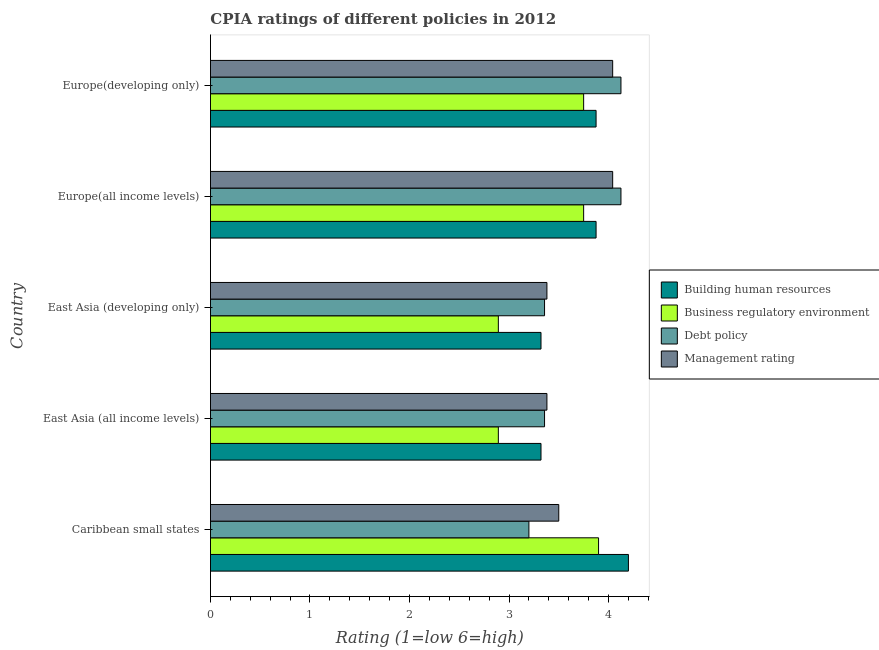What is the label of the 5th group of bars from the top?
Your answer should be compact. Caribbean small states. What is the cpia rating of debt policy in Europe(all income levels)?
Your response must be concise. 4.12. Across all countries, what is the maximum cpia rating of management?
Keep it short and to the point. 4.04. Across all countries, what is the minimum cpia rating of management?
Offer a terse response. 3.38. In which country was the cpia rating of building human resources maximum?
Offer a terse response. Caribbean small states. In which country was the cpia rating of business regulatory environment minimum?
Ensure brevity in your answer.  East Asia (all income levels). What is the total cpia rating of building human resources in the graph?
Make the answer very short. 18.59. What is the difference between the cpia rating of debt policy in East Asia (all income levels) and that in Europe(developing only)?
Provide a short and direct response. -0.77. What is the difference between the cpia rating of building human resources in East Asia (all income levels) and the cpia rating of debt policy in East Asia (developing only)?
Your response must be concise. -0.04. What is the average cpia rating of business regulatory environment per country?
Offer a terse response. 3.44. What is the difference between the cpia rating of business regulatory environment and cpia rating of building human resources in Europe(all income levels)?
Your answer should be compact. -0.12. What is the ratio of the cpia rating of building human resources in East Asia (all income levels) to that in East Asia (developing only)?
Provide a short and direct response. 1. Is the cpia rating of management in East Asia (all income levels) less than that in East Asia (developing only)?
Your answer should be compact. No. Is the difference between the cpia rating of management in Caribbean small states and East Asia (developing only) greater than the difference between the cpia rating of building human resources in Caribbean small states and East Asia (developing only)?
Your response must be concise. No. What is the difference between the highest and the second highest cpia rating of building human resources?
Give a very brief answer. 0.33. What is the difference between the highest and the lowest cpia rating of management?
Your answer should be compact. 0.66. What does the 2nd bar from the top in Caribbean small states represents?
Offer a terse response. Debt policy. What does the 4th bar from the bottom in Europe(developing only) represents?
Provide a succinct answer. Management rating. How many bars are there?
Give a very brief answer. 20. Are all the bars in the graph horizontal?
Give a very brief answer. Yes. How many countries are there in the graph?
Your response must be concise. 5. Are the values on the major ticks of X-axis written in scientific E-notation?
Offer a very short reply. No. Where does the legend appear in the graph?
Make the answer very short. Center right. How many legend labels are there?
Your answer should be compact. 4. What is the title of the graph?
Your response must be concise. CPIA ratings of different policies in 2012. What is the label or title of the X-axis?
Ensure brevity in your answer.  Rating (1=low 6=high). What is the Rating (1=low 6=high) in Building human resources in Caribbean small states?
Offer a terse response. 4.2. What is the Rating (1=low 6=high) in Building human resources in East Asia (all income levels)?
Offer a terse response. 3.32. What is the Rating (1=low 6=high) of Business regulatory environment in East Asia (all income levels)?
Provide a succinct answer. 2.89. What is the Rating (1=low 6=high) in Debt policy in East Asia (all income levels)?
Keep it short and to the point. 3.36. What is the Rating (1=low 6=high) of Management rating in East Asia (all income levels)?
Offer a very short reply. 3.38. What is the Rating (1=low 6=high) of Building human resources in East Asia (developing only)?
Provide a succinct answer. 3.32. What is the Rating (1=low 6=high) in Business regulatory environment in East Asia (developing only)?
Provide a succinct answer. 2.89. What is the Rating (1=low 6=high) of Debt policy in East Asia (developing only)?
Your answer should be very brief. 3.36. What is the Rating (1=low 6=high) in Management rating in East Asia (developing only)?
Provide a short and direct response. 3.38. What is the Rating (1=low 6=high) of Building human resources in Europe(all income levels)?
Make the answer very short. 3.88. What is the Rating (1=low 6=high) of Business regulatory environment in Europe(all income levels)?
Offer a terse response. 3.75. What is the Rating (1=low 6=high) of Debt policy in Europe(all income levels)?
Provide a succinct answer. 4.12. What is the Rating (1=low 6=high) of Management rating in Europe(all income levels)?
Offer a terse response. 4.04. What is the Rating (1=low 6=high) in Building human resources in Europe(developing only)?
Ensure brevity in your answer.  3.88. What is the Rating (1=low 6=high) in Business regulatory environment in Europe(developing only)?
Give a very brief answer. 3.75. What is the Rating (1=low 6=high) in Debt policy in Europe(developing only)?
Offer a terse response. 4.12. What is the Rating (1=low 6=high) of Management rating in Europe(developing only)?
Offer a terse response. 4.04. Across all countries, what is the maximum Rating (1=low 6=high) of Building human resources?
Give a very brief answer. 4.2. Across all countries, what is the maximum Rating (1=low 6=high) of Business regulatory environment?
Keep it short and to the point. 3.9. Across all countries, what is the maximum Rating (1=low 6=high) in Debt policy?
Provide a short and direct response. 4.12. Across all countries, what is the maximum Rating (1=low 6=high) of Management rating?
Offer a terse response. 4.04. Across all countries, what is the minimum Rating (1=low 6=high) in Building human resources?
Keep it short and to the point. 3.32. Across all countries, what is the minimum Rating (1=low 6=high) of Business regulatory environment?
Offer a very short reply. 2.89. Across all countries, what is the minimum Rating (1=low 6=high) of Debt policy?
Keep it short and to the point. 3.2. Across all countries, what is the minimum Rating (1=low 6=high) in Management rating?
Give a very brief answer. 3.38. What is the total Rating (1=low 6=high) in Building human resources in the graph?
Your response must be concise. 18.59. What is the total Rating (1=low 6=high) in Business regulatory environment in the graph?
Provide a short and direct response. 17.19. What is the total Rating (1=low 6=high) of Debt policy in the graph?
Ensure brevity in your answer.  18.16. What is the total Rating (1=low 6=high) of Management rating in the graph?
Your answer should be compact. 18.35. What is the difference between the Rating (1=low 6=high) in Building human resources in Caribbean small states and that in East Asia (all income levels)?
Your response must be concise. 0.88. What is the difference between the Rating (1=low 6=high) of Business regulatory environment in Caribbean small states and that in East Asia (all income levels)?
Keep it short and to the point. 1.01. What is the difference between the Rating (1=low 6=high) in Debt policy in Caribbean small states and that in East Asia (all income levels)?
Provide a succinct answer. -0.16. What is the difference between the Rating (1=low 6=high) of Management rating in Caribbean small states and that in East Asia (all income levels)?
Your answer should be compact. 0.12. What is the difference between the Rating (1=low 6=high) in Building human resources in Caribbean small states and that in East Asia (developing only)?
Your answer should be very brief. 0.88. What is the difference between the Rating (1=low 6=high) in Business regulatory environment in Caribbean small states and that in East Asia (developing only)?
Provide a succinct answer. 1.01. What is the difference between the Rating (1=low 6=high) of Debt policy in Caribbean small states and that in East Asia (developing only)?
Your answer should be compact. -0.16. What is the difference between the Rating (1=low 6=high) of Management rating in Caribbean small states and that in East Asia (developing only)?
Your answer should be very brief. 0.12. What is the difference between the Rating (1=low 6=high) of Building human resources in Caribbean small states and that in Europe(all income levels)?
Keep it short and to the point. 0.33. What is the difference between the Rating (1=low 6=high) in Debt policy in Caribbean small states and that in Europe(all income levels)?
Keep it short and to the point. -0.93. What is the difference between the Rating (1=low 6=high) in Management rating in Caribbean small states and that in Europe(all income levels)?
Ensure brevity in your answer.  -0.54. What is the difference between the Rating (1=low 6=high) of Building human resources in Caribbean small states and that in Europe(developing only)?
Provide a succinct answer. 0.33. What is the difference between the Rating (1=low 6=high) in Business regulatory environment in Caribbean small states and that in Europe(developing only)?
Your answer should be very brief. 0.15. What is the difference between the Rating (1=low 6=high) in Debt policy in Caribbean small states and that in Europe(developing only)?
Offer a terse response. -0.93. What is the difference between the Rating (1=low 6=high) in Management rating in Caribbean small states and that in Europe(developing only)?
Make the answer very short. -0.54. What is the difference between the Rating (1=low 6=high) in Debt policy in East Asia (all income levels) and that in East Asia (developing only)?
Your answer should be compact. 0. What is the difference between the Rating (1=low 6=high) in Building human resources in East Asia (all income levels) and that in Europe(all income levels)?
Your answer should be compact. -0.55. What is the difference between the Rating (1=low 6=high) of Business regulatory environment in East Asia (all income levels) and that in Europe(all income levels)?
Offer a very short reply. -0.86. What is the difference between the Rating (1=low 6=high) in Debt policy in East Asia (all income levels) and that in Europe(all income levels)?
Offer a very short reply. -0.77. What is the difference between the Rating (1=low 6=high) of Management rating in East Asia (all income levels) and that in Europe(all income levels)?
Your answer should be very brief. -0.66. What is the difference between the Rating (1=low 6=high) of Building human resources in East Asia (all income levels) and that in Europe(developing only)?
Your response must be concise. -0.55. What is the difference between the Rating (1=low 6=high) of Business regulatory environment in East Asia (all income levels) and that in Europe(developing only)?
Provide a short and direct response. -0.86. What is the difference between the Rating (1=low 6=high) in Debt policy in East Asia (all income levels) and that in Europe(developing only)?
Offer a terse response. -0.77. What is the difference between the Rating (1=low 6=high) in Management rating in East Asia (all income levels) and that in Europe(developing only)?
Offer a terse response. -0.66. What is the difference between the Rating (1=low 6=high) of Building human resources in East Asia (developing only) and that in Europe(all income levels)?
Keep it short and to the point. -0.55. What is the difference between the Rating (1=low 6=high) of Business regulatory environment in East Asia (developing only) and that in Europe(all income levels)?
Your response must be concise. -0.86. What is the difference between the Rating (1=low 6=high) of Debt policy in East Asia (developing only) and that in Europe(all income levels)?
Offer a very short reply. -0.77. What is the difference between the Rating (1=low 6=high) of Management rating in East Asia (developing only) and that in Europe(all income levels)?
Your answer should be compact. -0.66. What is the difference between the Rating (1=low 6=high) of Building human resources in East Asia (developing only) and that in Europe(developing only)?
Keep it short and to the point. -0.55. What is the difference between the Rating (1=low 6=high) in Business regulatory environment in East Asia (developing only) and that in Europe(developing only)?
Provide a short and direct response. -0.86. What is the difference between the Rating (1=low 6=high) of Debt policy in East Asia (developing only) and that in Europe(developing only)?
Your answer should be compact. -0.77. What is the difference between the Rating (1=low 6=high) in Management rating in East Asia (developing only) and that in Europe(developing only)?
Make the answer very short. -0.66. What is the difference between the Rating (1=low 6=high) in Building human resources in Europe(all income levels) and that in Europe(developing only)?
Your answer should be very brief. 0. What is the difference between the Rating (1=low 6=high) in Debt policy in Europe(all income levels) and that in Europe(developing only)?
Give a very brief answer. 0. What is the difference between the Rating (1=low 6=high) in Building human resources in Caribbean small states and the Rating (1=low 6=high) in Business regulatory environment in East Asia (all income levels)?
Offer a terse response. 1.31. What is the difference between the Rating (1=low 6=high) of Building human resources in Caribbean small states and the Rating (1=low 6=high) of Debt policy in East Asia (all income levels)?
Offer a terse response. 0.84. What is the difference between the Rating (1=low 6=high) of Building human resources in Caribbean small states and the Rating (1=low 6=high) of Management rating in East Asia (all income levels)?
Provide a succinct answer. 0.82. What is the difference between the Rating (1=low 6=high) in Business regulatory environment in Caribbean small states and the Rating (1=low 6=high) in Debt policy in East Asia (all income levels)?
Keep it short and to the point. 0.54. What is the difference between the Rating (1=low 6=high) of Business regulatory environment in Caribbean small states and the Rating (1=low 6=high) of Management rating in East Asia (all income levels)?
Your answer should be very brief. 0.52. What is the difference between the Rating (1=low 6=high) in Debt policy in Caribbean small states and the Rating (1=low 6=high) in Management rating in East Asia (all income levels)?
Offer a terse response. -0.18. What is the difference between the Rating (1=low 6=high) of Building human resources in Caribbean small states and the Rating (1=low 6=high) of Business regulatory environment in East Asia (developing only)?
Provide a succinct answer. 1.31. What is the difference between the Rating (1=low 6=high) of Building human resources in Caribbean small states and the Rating (1=low 6=high) of Debt policy in East Asia (developing only)?
Keep it short and to the point. 0.84. What is the difference between the Rating (1=low 6=high) of Building human resources in Caribbean small states and the Rating (1=low 6=high) of Management rating in East Asia (developing only)?
Provide a succinct answer. 0.82. What is the difference between the Rating (1=low 6=high) in Business regulatory environment in Caribbean small states and the Rating (1=low 6=high) in Debt policy in East Asia (developing only)?
Provide a short and direct response. 0.54. What is the difference between the Rating (1=low 6=high) of Business regulatory environment in Caribbean small states and the Rating (1=low 6=high) of Management rating in East Asia (developing only)?
Give a very brief answer. 0.52. What is the difference between the Rating (1=low 6=high) of Debt policy in Caribbean small states and the Rating (1=low 6=high) of Management rating in East Asia (developing only)?
Keep it short and to the point. -0.18. What is the difference between the Rating (1=low 6=high) in Building human resources in Caribbean small states and the Rating (1=low 6=high) in Business regulatory environment in Europe(all income levels)?
Your response must be concise. 0.45. What is the difference between the Rating (1=low 6=high) of Building human resources in Caribbean small states and the Rating (1=low 6=high) of Debt policy in Europe(all income levels)?
Your answer should be compact. 0.07. What is the difference between the Rating (1=low 6=high) in Building human resources in Caribbean small states and the Rating (1=low 6=high) in Management rating in Europe(all income levels)?
Provide a succinct answer. 0.16. What is the difference between the Rating (1=low 6=high) of Business regulatory environment in Caribbean small states and the Rating (1=low 6=high) of Debt policy in Europe(all income levels)?
Offer a terse response. -0.23. What is the difference between the Rating (1=low 6=high) in Business regulatory environment in Caribbean small states and the Rating (1=low 6=high) in Management rating in Europe(all income levels)?
Make the answer very short. -0.14. What is the difference between the Rating (1=low 6=high) in Debt policy in Caribbean small states and the Rating (1=low 6=high) in Management rating in Europe(all income levels)?
Keep it short and to the point. -0.84. What is the difference between the Rating (1=low 6=high) in Building human resources in Caribbean small states and the Rating (1=low 6=high) in Business regulatory environment in Europe(developing only)?
Provide a short and direct response. 0.45. What is the difference between the Rating (1=low 6=high) in Building human resources in Caribbean small states and the Rating (1=low 6=high) in Debt policy in Europe(developing only)?
Your answer should be compact. 0.07. What is the difference between the Rating (1=low 6=high) in Building human resources in Caribbean small states and the Rating (1=low 6=high) in Management rating in Europe(developing only)?
Your response must be concise. 0.16. What is the difference between the Rating (1=low 6=high) of Business regulatory environment in Caribbean small states and the Rating (1=low 6=high) of Debt policy in Europe(developing only)?
Make the answer very short. -0.23. What is the difference between the Rating (1=low 6=high) of Business regulatory environment in Caribbean small states and the Rating (1=low 6=high) of Management rating in Europe(developing only)?
Offer a very short reply. -0.14. What is the difference between the Rating (1=low 6=high) of Debt policy in Caribbean small states and the Rating (1=low 6=high) of Management rating in Europe(developing only)?
Offer a very short reply. -0.84. What is the difference between the Rating (1=low 6=high) of Building human resources in East Asia (all income levels) and the Rating (1=low 6=high) of Business regulatory environment in East Asia (developing only)?
Offer a terse response. 0.43. What is the difference between the Rating (1=low 6=high) in Building human resources in East Asia (all income levels) and the Rating (1=low 6=high) in Debt policy in East Asia (developing only)?
Your answer should be very brief. -0.04. What is the difference between the Rating (1=low 6=high) in Building human resources in East Asia (all income levels) and the Rating (1=low 6=high) in Management rating in East Asia (developing only)?
Your response must be concise. -0.06. What is the difference between the Rating (1=low 6=high) of Business regulatory environment in East Asia (all income levels) and the Rating (1=low 6=high) of Debt policy in East Asia (developing only)?
Make the answer very short. -0.46. What is the difference between the Rating (1=low 6=high) of Business regulatory environment in East Asia (all income levels) and the Rating (1=low 6=high) of Management rating in East Asia (developing only)?
Give a very brief answer. -0.49. What is the difference between the Rating (1=low 6=high) in Debt policy in East Asia (all income levels) and the Rating (1=low 6=high) in Management rating in East Asia (developing only)?
Your answer should be very brief. -0.02. What is the difference between the Rating (1=low 6=high) in Building human resources in East Asia (all income levels) and the Rating (1=low 6=high) in Business regulatory environment in Europe(all income levels)?
Keep it short and to the point. -0.43. What is the difference between the Rating (1=low 6=high) in Building human resources in East Asia (all income levels) and the Rating (1=low 6=high) in Debt policy in Europe(all income levels)?
Give a very brief answer. -0.8. What is the difference between the Rating (1=low 6=high) of Building human resources in East Asia (all income levels) and the Rating (1=low 6=high) of Management rating in Europe(all income levels)?
Ensure brevity in your answer.  -0.72. What is the difference between the Rating (1=low 6=high) of Business regulatory environment in East Asia (all income levels) and the Rating (1=low 6=high) of Debt policy in Europe(all income levels)?
Offer a very short reply. -1.23. What is the difference between the Rating (1=low 6=high) of Business regulatory environment in East Asia (all income levels) and the Rating (1=low 6=high) of Management rating in Europe(all income levels)?
Provide a short and direct response. -1.15. What is the difference between the Rating (1=low 6=high) in Debt policy in East Asia (all income levels) and the Rating (1=low 6=high) in Management rating in Europe(all income levels)?
Offer a terse response. -0.68. What is the difference between the Rating (1=low 6=high) of Building human resources in East Asia (all income levels) and the Rating (1=low 6=high) of Business regulatory environment in Europe(developing only)?
Your response must be concise. -0.43. What is the difference between the Rating (1=low 6=high) in Building human resources in East Asia (all income levels) and the Rating (1=low 6=high) in Debt policy in Europe(developing only)?
Make the answer very short. -0.8. What is the difference between the Rating (1=low 6=high) of Building human resources in East Asia (all income levels) and the Rating (1=low 6=high) of Management rating in Europe(developing only)?
Offer a terse response. -0.72. What is the difference between the Rating (1=low 6=high) of Business regulatory environment in East Asia (all income levels) and the Rating (1=low 6=high) of Debt policy in Europe(developing only)?
Offer a very short reply. -1.23. What is the difference between the Rating (1=low 6=high) in Business regulatory environment in East Asia (all income levels) and the Rating (1=low 6=high) in Management rating in Europe(developing only)?
Give a very brief answer. -1.15. What is the difference between the Rating (1=low 6=high) of Debt policy in East Asia (all income levels) and the Rating (1=low 6=high) of Management rating in Europe(developing only)?
Your response must be concise. -0.68. What is the difference between the Rating (1=low 6=high) in Building human resources in East Asia (developing only) and the Rating (1=low 6=high) in Business regulatory environment in Europe(all income levels)?
Ensure brevity in your answer.  -0.43. What is the difference between the Rating (1=low 6=high) in Building human resources in East Asia (developing only) and the Rating (1=low 6=high) in Debt policy in Europe(all income levels)?
Your response must be concise. -0.8. What is the difference between the Rating (1=low 6=high) of Building human resources in East Asia (developing only) and the Rating (1=low 6=high) of Management rating in Europe(all income levels)?
Your answer should be very brief. -0.72. What is the difference between the Rating (1=low 6=high) in Business regulatory environment in East Asia (developing only) and the Rating (1=low 6=high) in Debt policy in Europe(all income levels)?
Make the answer very short. -1.23. What is the difference between the Rating (1=low 6=high) in Business regulatory environment in East Asia (developing only) and the Rating (1=low 6=high) in Management rating in Europe(all income levels)?
Make the answer very short. -1.15. What is the difference between the Rating (1=low 6=high) of Debt policy in East Asia (developing only) and the Rating (1=low 6=high) of Management rating in Europe(all income levels)?
Make the answer very short. -0.68. What is the difference between the Rating (1=low 6=high) in Building human resources in East Asia (developing only) and the Rating (1=low 6=high) in Business regulatory environment in Europe(developing only)?
Give a very brief answer. -0.43. What is the difference between the Rating (1=low 6=high) of Building human resources in East Asia (developing only) and the Rating (1=low 6=high) of Debt policy in Europe(developing only)?
Offer a very short reply. -0.8. What is the difference between the Rating (1=low 6=high) in Building human resources in East Asia (developing only) and the Rating (1=low 6=high) in Management rating in Europe(developing only)?
Your answer should be compact. -0.72. What is the difference between the Rating (1=low 6=high) in Business regulatory environment in East Asia (developing only) and the Rating (1=low 6=high) in Debt policy in Europe(developing only)?
Your response must be concise. -1.23. What is the difference between the Rating (1=low 6=high) in Business regulatory environment in East Asia (developing only) and the Rating (1=low 6=high) in Management rating in Europe(developing only)?
Give a very brief answer. -1.15. What is the difference between the Rating (1=low 6=high) in Debt policy in East Asia (developing only) and the Rating (1=low 6=high) in Management rating in Europe(developing only)?
Your response must be concise. -0.68. What is the difference between the Rating (1=low 6=high) of Building human resources in Europe(all income levels) and the Rating (1=low 6=high) of Business regulatory environment in Europe(developing only)?
Keep it short and to the point. 0.12. What is the difference between the Rating (1=low 6=high) of Building human resources in Europe(all income levels) and the Rating (1=low 6=high) of Management rating in Europe(developing only)?
Your response must be concise. -0.17. What is the difference between the Rating (1=low 6=high) in Business regulatory environment in Europe(all income levels) and the Rating (1=low 6=high) in Debt policy in Europe(developing only)?
Keep it short and to the point. -0.38. What is the difference between the Rating (1=low 6=high) in Business regulatory environment in Europe(all income levels) and the Rating (1=low 6=high) in Management rating in Europe(developing only)?
Make the answer very short. -0.29. What is the difference between the Rating (1=low 6=high) in Debt policy in Europe(all income levels) and the Rating (1=low 6=high) in Management rating in Europe(developing only)?
Provide a short and direct response. 0.08. What is the average Rating (1=low 6=high) of Building human resources per country?
Make the answer very short. 3.72. What is the average Rating (1=low 6=high) of Business regulatory environment per country?
Provide a succinct answer. 3.44. What is the average Rating (1=low 6=high) in Debt policy per country?
Give a very brief answer. 3.63. What is the average Rating (1=low 6=high) of Management rating per country?
Make the answer very short. 3.67. What is the difference between the Rating (1=low 6=high) of Building human resources and Rating (1=low 6=high) of Debt policy in Caribbean small states?
Provide a succinct answer. 1. What is the difference between the Rating (1=low 6=high) of Debt policy and Rating (1=low 6=high) of Management rating in Caribbean small states?
Offer a very short reply. -0.3. What is the difference between the Rating (1=low 6=high) in Building human resources and Rating (1=low 6=high) in Business regulatory environment in East Asia (all income levels)?
Give a very brief answer. 0.43. What is the difference between the Rating (1=low 6=high) in Building human resources and Rating (1=low 6=high) in Debt policy in East Asia (all income levels)?
Offer a terse response. -0.04. What is the difference between the Rating (1=low 6=high) of Building human resources and Rating (1=low 6=high) of Management rating in East Asia (all income levels)?
Ensure brevity in your answer.  -0.06. What is the difference between the Rating (1=low 6=high) of Business regulatory environment and Rating (1=low 6=high) of Debt policy in East Asia (all income levels)?
Ensure brevity in your answer.  -0.46. What is the difference between the Rating (1=low 6=high) of Business regulatory environment and Rating (1=low 6=high) of Management rating in East Asia (all income levels)?
Provide a short and direct response. -0.49. What is the difference between the Rating (1=low 6=high) of Debt policy and Rating (1=low 6=high) of Management rating in East Asia (all income levels)?
Provide a succinct answer. -0.02. What is the difference between the Rating (1=low 6=high) in Building human resources and Rating (1=low 6=high) in Business regulatory environment in East Asia (developing only)?
Make the answer very short. 0.43. What is the difference between the Rating (1=low 6=high) of Building human resources and Rating (1=low 6=high) of Debt policy in East Asia (developing only)?
Your response must be concise. -0.04. What is the difference between the Rating (1=low 6=high) of Building human resources and Rating (1=low 6=high) of Management rating in East Asia (developing only)?
Your answer should be compact. -0.06. What is the difference between the Rating (1=low 6=high) in Business regulatory environment and Rating (1=low 6=high) in Debt policy in East Asia (developing only)?
Your answer should be very brief. -0.46. What is the difference between the Rating (1=low 6=high) in Business regulatory environment and Rating (1=low 6=high) in Management rating in East Asia (developing only)?
Offer a terse response. -0.49. What is the difference between the Rating (1=low 6=high) in Debt policy and Rating (1=low 6=high) in Management rating in East Asia (developing only)?
Give a very brief answer. -0.02. What is the difference between the Rating (1=low 6=high) in Building human resources and Rating (1=low 6=high) in Business regulatory environment in Europe(all income levels)?
Ensure brevity in your answer.  0.12. What is the difference between the Rating (1=low 6=high) of Building human resources and Rating (1=low 6=high) of Debt policy in Europe(all income levels)?
Offer a terse response. -0.25. What is the difference between the Rating (1=low 6=high) of Building human resources and Rating (1=low 6=high) of Management rating in Europe(all income levels)?
Give a very brief answer. -0.17. What is the difference between the Rating (1=low 6=high) in Business regulatory environment and Rating (1=low 6=high) in Debt policy in Europe(all income levels)?
Offer a terse response. -0.38. What is the difference between the Rating (1=low 6=high) of Business regulatory environment and Rating (1=low 6=high) of Management rating in Europe(all income levels)?
Make the answer very short. -0.29. What is the difference between the Rating (1=low 6=high) in Debt policy and Rating (1=low 6=high) in Management rating in Europe(all income levels)?
Make the answer very short. 0.08. What is the difference between the Rating (1=low 6=high) in Building human resources and Rating (1=low 6=high) in Debt policy in Europe(developing only)?
Keep it short and to the point. -0.25. What is the difference between the Rating (1=low 6=high) of Business regulatory environment and Rating (1=low 6=high) of Debt policy in Europe(developing only)?
Your answer should be very brief. -0.38. What is the difference between the Rating (1=low 6=high) of Business regulatory environment and Rating (1=low 6=high) of Management rating in Europe(developing only)?
Provide a succinct answer. -0.29. What is the difference between the Rating (1=low 6=high) in Debt policy and Rating (1=low 6=high) in Management rating in Europe(developing only)?
Your response must be concise. 0.08. What is the ratio of the Rating (1=low 6=high) in Building human resources in Caribbean small states to that in East Asia (all income levels)?
Provide a short and direct response. 1.26. What is the ratio of the Rating (1=low 6=high) of Business regulatory environment in Caribbean small states to that in East Asia (all income levels)?
Provide a short and direct response. 1.35. What is the ratio of the Rating (1=low 6=high) of Debt policy in Caribbean small states to that in East Asia (all income levels)?
Ensure brevity in your answer.  0.95. What is the ratio of the Rating (1=low 6=high) in Management rating in Caribbean small states to that in East Asia (all income levels)?
Keep it short and to the point. 1.04. What is the ratio of the Rating (1=low 6=high) in Building human resources in Caribbean small states to that in East Asia (developing only)?
Provide a succinct answer. 1.26. What is the ratio of the Rating (1=low 6=high) in Business regulatory environment in Caribbean small states to that in East Asia (developing only)?
Your answer should be very brief. 1.35. What is the ratio of the Rating (1=low 6=high) in Debt policy in Caribbean small states to that in East Asia (developing only)?
Provide a succinct answer. 0.95. What is the ratio of the Rating (1=low 6=high) in Management rating in Caribbean small states to that in East Asia (developing only)?
Provide a short and direct response. 1.04. What is the ratio of the Rating (1=low 6=high) of Building human resources in Caribbean small states to that in Europe(all income levels)?
Provide a succinct answer. 1.08. What is the ratio of the Rating (1=low 6=high) of Debt policy in Caribbean small states to that in Europe(all income levels)?
Ensure brevity in your answer.  0.78. What is the ratio of the Rating (1=low 6=high) in Management rating in Caribbean small states to that in Europe(all income levels)?
Provide a short and direct response. 0.87. What is the ratio of the Rating (1=low 6=high) in Building human resources in Caribbean small states to that in Europe(developing only)?
Offer a terse response. 1.08. What is the ratio of the Rating (1=low 6=high) in Business regulatory environment in Caribbean small states to that in Europe(developing only)?
Ensure brevity in your answer.  1.04. What is the ratio of the Rating (1=low 6=high) in Debt policy in Caribbean small states to that in Europe(developing only)?
Offer a terse response. 0.78. What is the ratio of the Rating (1=low 6=high) in Management rating in Caribbean small states to that in Europe(developing only)?
Provide a short and direct response. 0.87. What is the ratio of the Rating (1=low 6=high) of Debt policy in East Asia (all income levels) to that in East Asia (developing only)?
Your answer should be compact. 1. What is the ratio of the Rating (1=low 6=high) in Management rating in East Asia (all income levels) to that in East Asia (developing only)?
Provide a succinct answer. 1. What is the ratio of the Rating (1=low 6=high) in Business regulatory environment in East Asia (all income levels) to that in Europe(all income levels)?
Your answer should be very brief. 0.77. What is the ratio of the Rating (1=low 6=high) in Debt policy in East Asia (all income levels) to that in Europe(all income levels)?
Your answer should be very brief. 0.81. What is the ratio of the Rating (1=low 6=high) of Management rating in East Asia (all income levels) to that in Europe(all income levels)?
Give a very brief answer. 0.84. What is the ratio of the Rating (1=low 6=high) in Business regulatory environment in East Asia (all income levels) to that in Europe(developing only)?
Offer a terse response. 0.77. What is the ratio of the Rating (1=low 6=high) of Debt policy in East Asia (all income levels) to that in Europe(developing only)?
Offer a very short reply. 0.81. What is the ratio of the Rating (1=low 6=high) in Management rating in East Asia (all income levels) to that in Europe(developing only)?
Your answer should be very brief. 0.84. What is the ratio of the Rating (1=low 6=high) of Business regulatory environment in East Asia (developing only) to that in Europe(all income levels)?
Offer a terse response. 0.77. What is the ratio of the Rating (1=low 6=high) in Debt policy in East Asia (developing only) to that in Europe(all income levels)?
Offer a terse response. 0.81. What is the ratio of the Rating (1=low 6=high) in Management rating in East Asia (developing only) to that in Europe(all income levels)?
Keep it short and to the point. 0.84. What is the ratio of the Rating (1=low 6=high) in Business regulatory environment in East Asia (developing only) to that in Europe(developing only)?
Your answer should be compact. 0.77. What is the ratio of the Rating (1=low 6=high) of Debt policy in East Asia (developing only) to that in Europe(developing only)?
Your answer should be very brief. 0.81. What is the ratio of the Rating (1=low 6=high) in Management rating in East Asia (developing only) to that in Europe(developing only)?
Provide a short and direct response. 0.84. What is the ratio of the Rating (1=low 6=high) in Building human resources in Europe(all income levels) to that in Europe(developing only)?
Give a very brief answer. 1. What is the difference between the highest and the second highest Rating (1=low 6=high) of Building human resources?
Keep it short and to the point. 0.33. What is the difference between the highest and the lowest Rating (1=low 6=high) in Building human resources?
Your response must be concise. 0.88. What is the difference between the highest and the lowest Rating (1=low 6=high) of Business regulatory environment?
Provide a short and direct response. 1.01. What is the difference between the highest and the lowest Rating (1=low 6=high) of Debt policy?
Your response must be concise. 0.93. What is the difference between the highest and the lowest Rating (1=low 6=high) in Management rating?
Your answer should be compact. 0.66. 